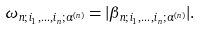Convert formula to latex. <formula><loc_0><loc_0><loc_500><loc_500>\omega _ { n ; i _ { 1 } , \dots , i _ { n } ; \alpha ^ { ( n ) } } = | \beta _ { n ; i _ { 1 } , \dots , i _ { n } ; \alpha ^ { ( n ) } } | .</formula> 